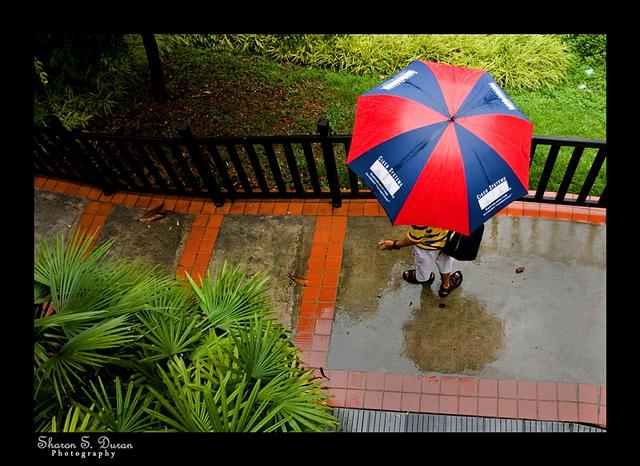Is it raining?
Write a very short answer. Yes. What colors are the umbrella?
Write a very short answer. Red, blue and white. What color is the umbrella?
Concise answer only. Red and blue. Has it been raining?
Write a very short answer. Yes. 